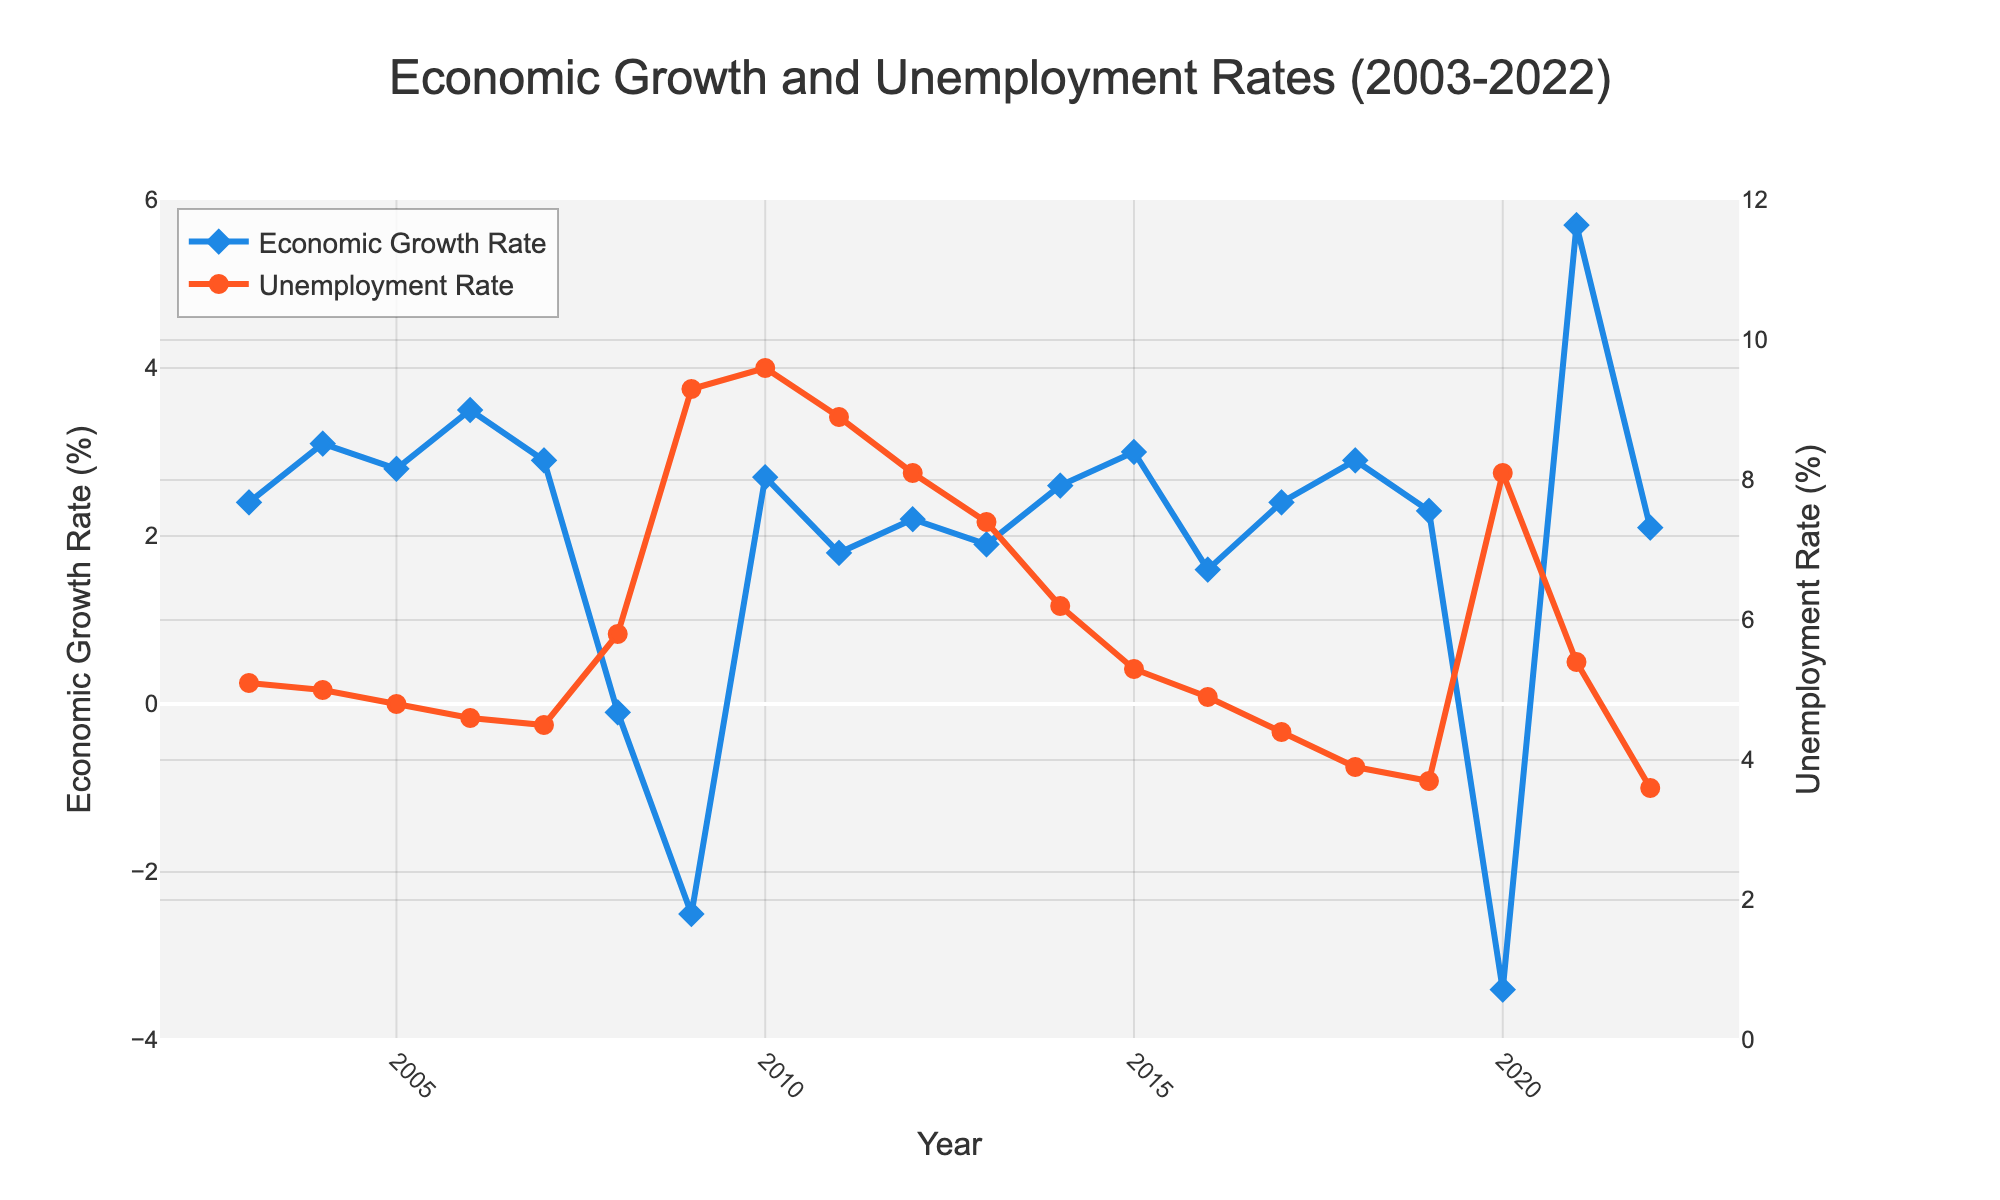What is the title of the figure? The title is present at the top of the figure. It reads "Economic Growth and Unemployment Rates (2003-2022)."
Answer: Economic Growth and Unemployment Rates (2003-2022) How many years of data are displayed in the figure? The x-axis shows the year range from 2003 to 2022. Counting all these years, it covers 20 years.
Answer: 20 What was the Unemployment Rate in 2009? Locate the year 2009 on the x-axis and follow the corresponding point on the Unemployment Rate line (orange line). The value is approximately 9.3%.
Answer: 9.3% Which year experienced the lowest Economic Growth Rate? Identify the lowest point on the Economic Growth Rate line (blue line). The most negative value occurs in 2020, where the growth rate is approximately -3.4%.
Answer: 2020 Are there any years where both Economic Growth Rate and Unemployment Rate increased simultaneously? Look at the trends for both lines:
1. Identify sections where the Economic Growth Rate line goes upwards.
2. Check if during the same periods, the Unemployment Rate line also goes upwards.
For example, from 2020 to 2021, both the Economic Growth Rate (-3.4% to 5.7%) and the Unemployment Rate (8.1% to 5.4%) increase.
Answer: 2020 to 2021 In which year did the Economic Growth Rate recover substantially after a decline? Observe significant declines and recoveries in the Economic Growth Rate line:
One notable instance is from 2020 (-3.4%) to 2021 (5.7%), indicating a substantial recovery.
Answer: 2021 During which period did the Unemployment Rate show a continuous decline? Look for periods where the Unemployment Rate line (orange line) keeps moving downward without reversal:
- From 2010 (9.6%) to 2019 (3.7%), it showed a continuous decline.
Answer: 2010 to 2019 Which year had the highest Economic Growth Rate, and what was the corresponding Unemployment Rate for that year? Find the highest point on the Economic Growth Rate line: 
- The peak occurs in 2021, with a rate of 5.7%.
- The corresponding Unemployment Rate in 2021 was 5.4%.
Answer: 2021, 5.4% What is the general trend in the relationship between Economic Growth Rate and Unemployment Rate over two decades? Analyze the overall trend of both lines over time:
- Generally, higher Economic Growth Rates tend to have a corresponding lower Unemployment Rate, and vice versa.
- For example, during economic downturns (2008-2009, 2020), the Unemployment Rate spikes.
Answer: Higher growth generally correlates with lower unemployment 